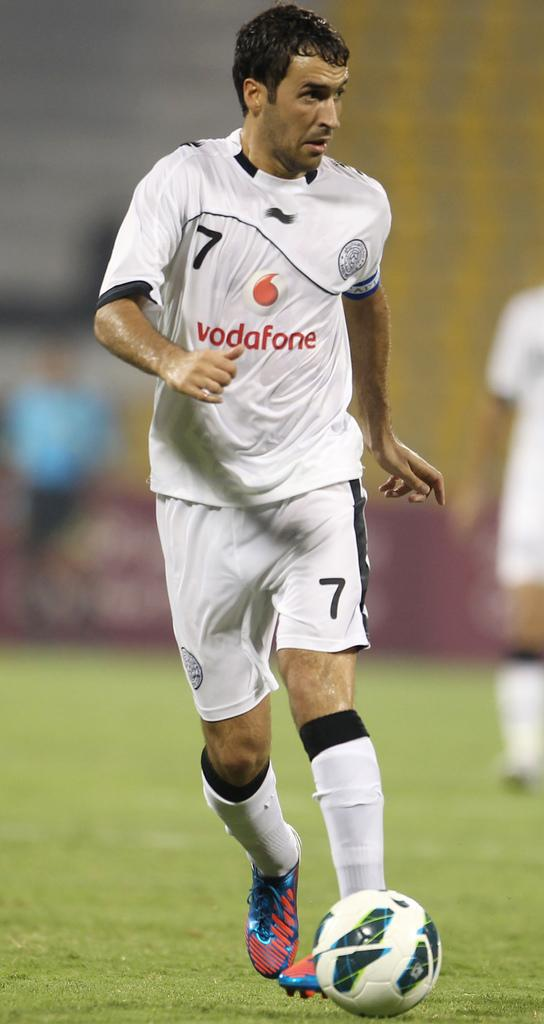What is the main subject of the image? There is a person in the image. What is the person doing in the image? The person is hitting a ball. Can you describe the setting where the person is located? The setting appears to be a court, and the court is green in color. What type of cracker is the person holding in the image? There is no cracker present in the image; the person is hitting a ball. 